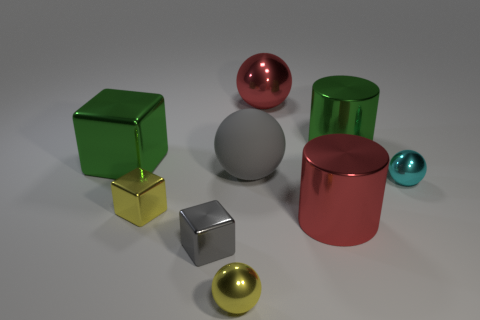Subtract all cylinders. How many objects are left? 7 Add 1 tiny objects. How many tiny objects are left? 5 Add 7 small cyan shiny spheres. How many small cyan shiny spheres exist? 8 Subtract 1 yellow balls. How many objects are left? 8 Subtract all small objects. Subtract all red balls. How many objects are left? 4 